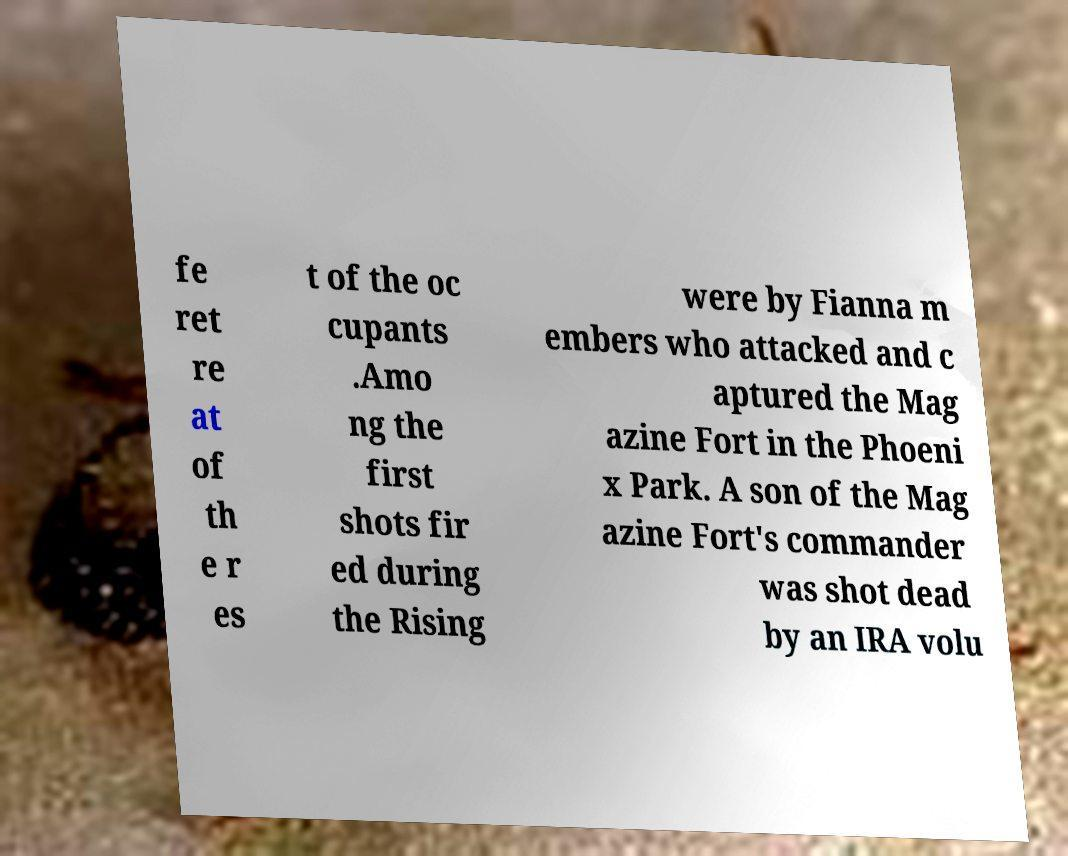What messages or text are displayed in this image? I need them in a readable, typed format. fe ret re at of th e r es t of the oc cupants .Amo ng the first shots fir ed during the Rising were by Fianna m embers who attacked and c aptured the Mag azine Fort in the Phoeni x Park. A son of the Mag azine Fort's commander was shot dead by an IRA volu 